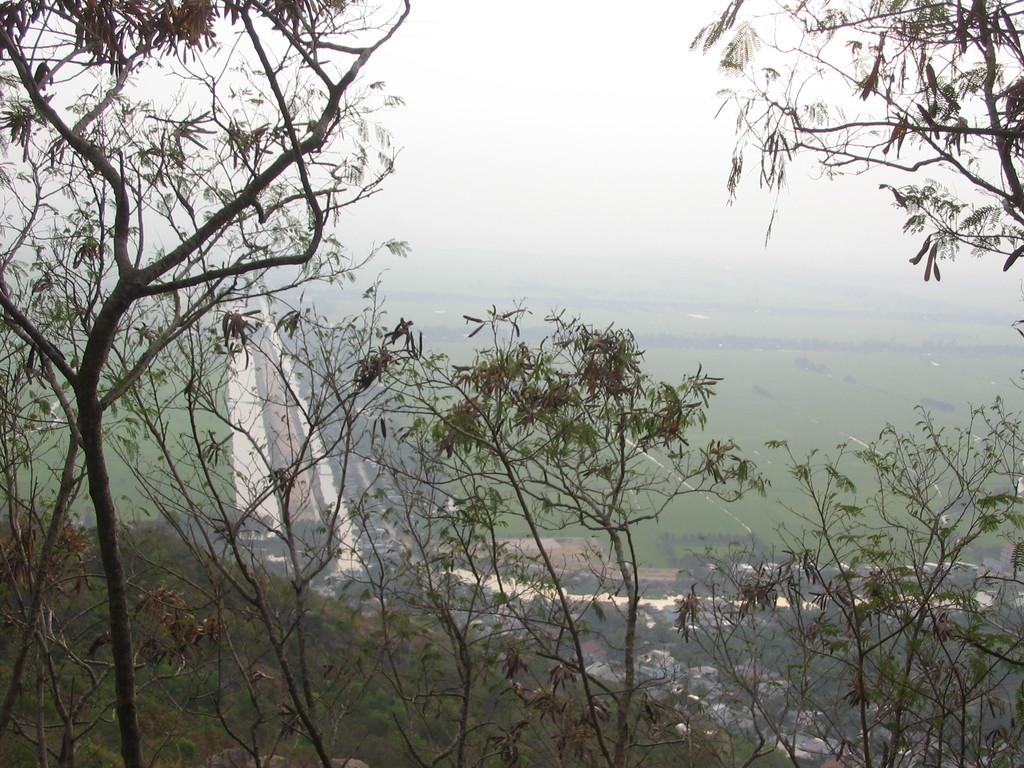What type of vegetation is at the bottom of the image? There are trees at the bottom of the image. What can be seen in the background of the image? There is greenery in the background of the image. What is visible at the top of the image? The sky is visible at the top of the image. What color is the crayon used to draw the trees in the image? There is no crayon present in the image; the trees are depicted as they would appear in real life. Is there a cord attached to the greenery in the background? There is no cord visible in the image; the greenery is part of the natural landscape. 